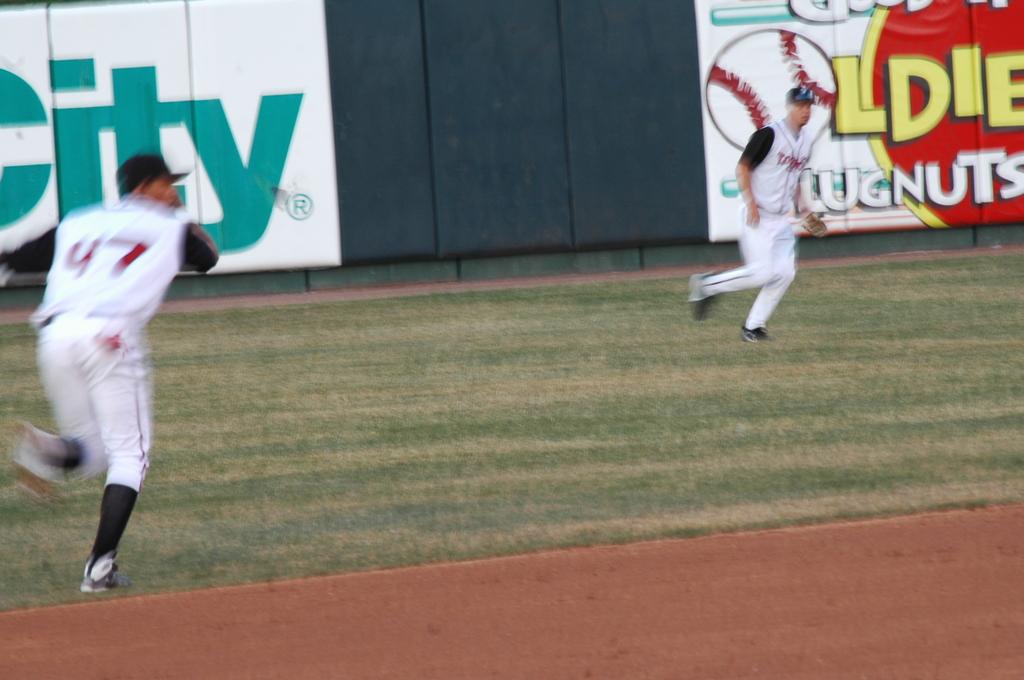What is the top right ad advertising?
Provide a succinct answer. Lugnuts. 